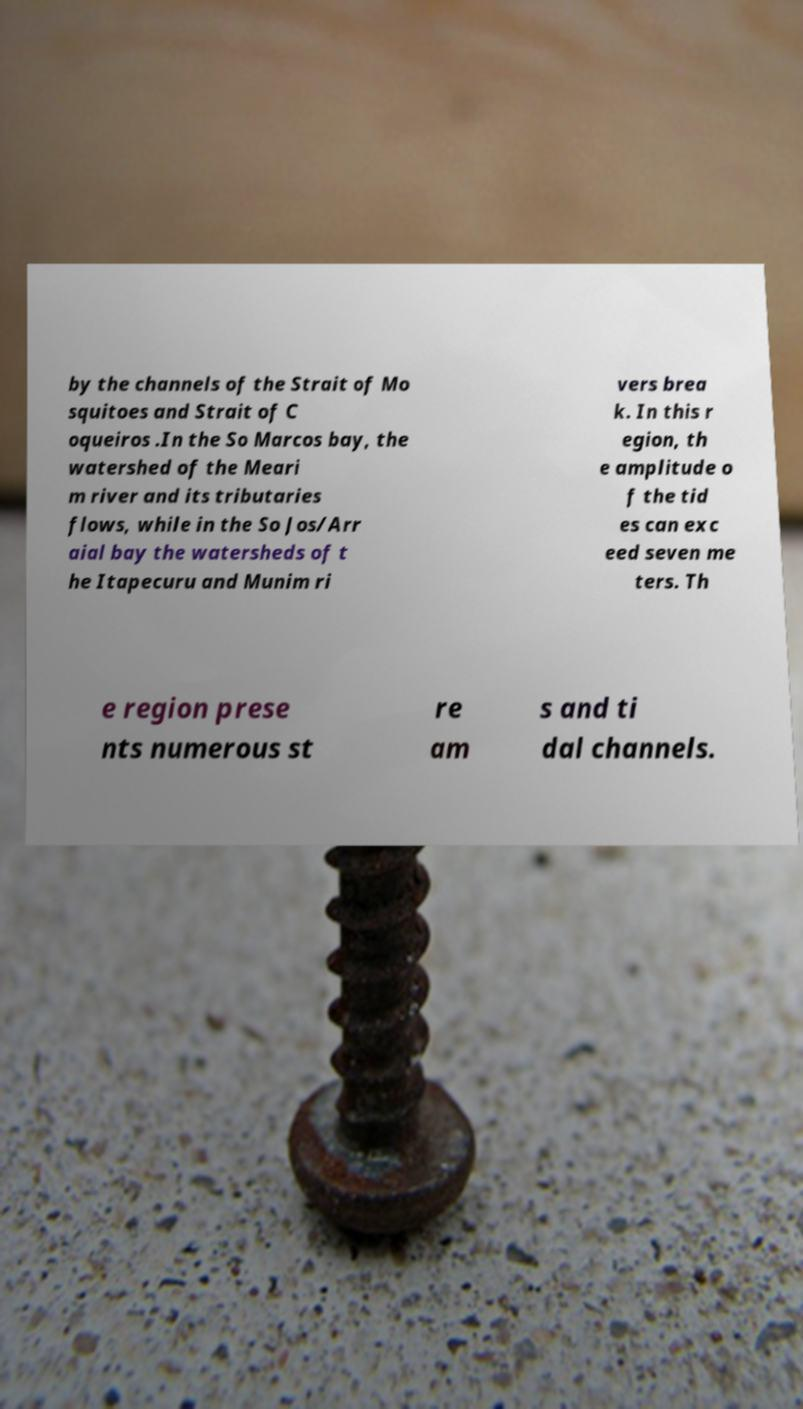Can you accurately transcribe the text from the provided image for me? by the channels of the Strait of Mo squitoes and Strait of C oqueiros .In the So Marcos bay, the watershed of the Meari m river and its tributaries flows, while in the So Jos/Arr aial bay the watersheds of t he Itapecuru and Munim ri vers brea k. In this r egion, th e amplitude o f the tid es can exc eed seven me ters. Th e region prese nts numerous st re am s and ti dal channels. 